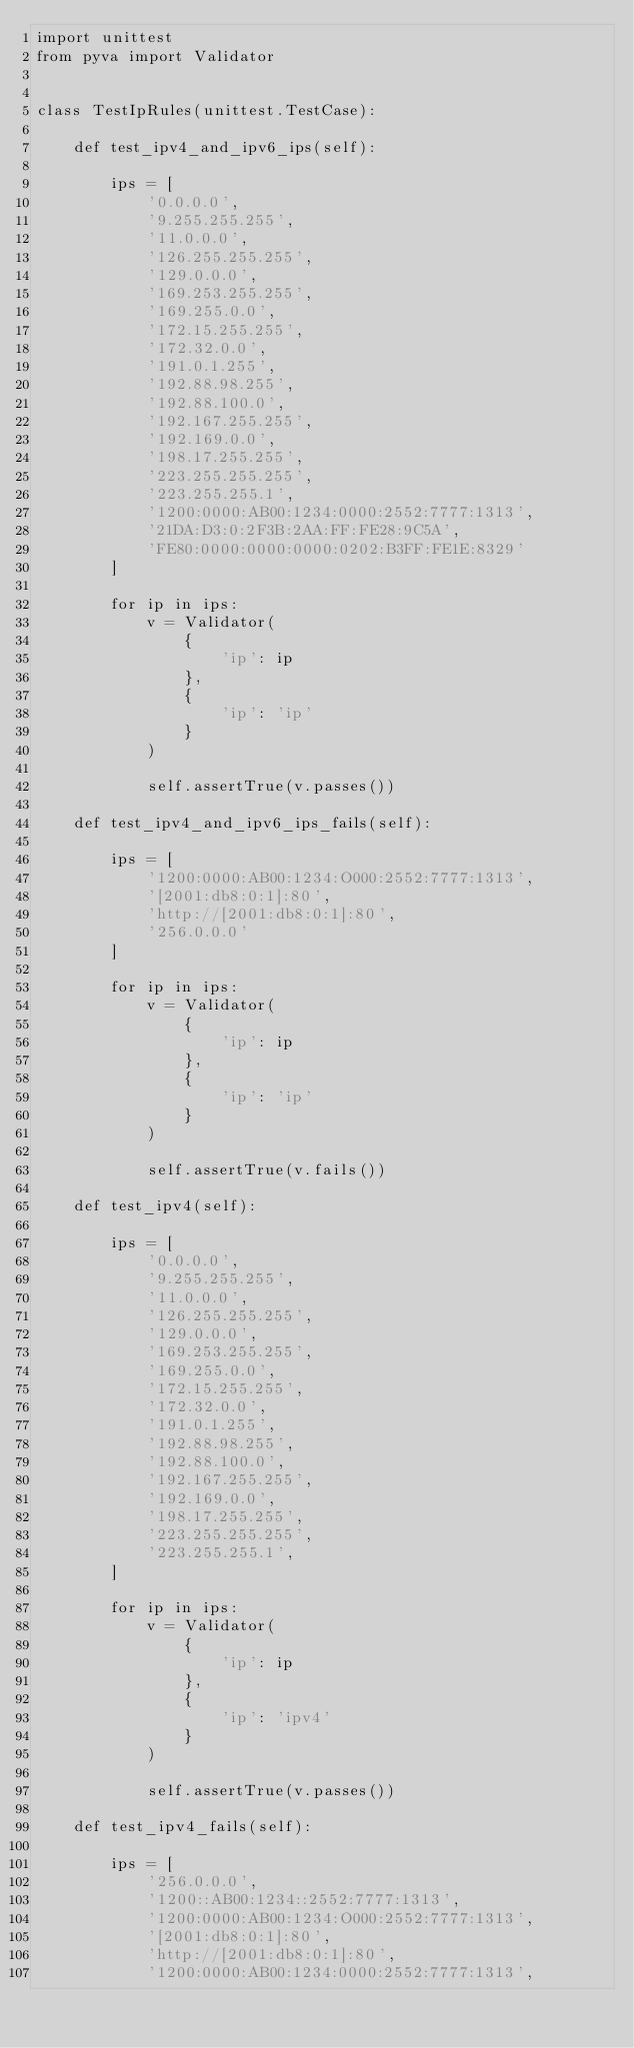Convert code to text. <code><loc_0><loc_0><loc_500><loc_500><_Python_>import unittest
from pyva import Validator


class TestIpRules(unittest.TestCase):

    def test_ipv4_and_ipv6_ips(self):

        ips = [
            '0.0.0.0',
            '9.255.255.255',
            '11.0.0.0',
            '126.255.255.255',
            '129.0.0.0',
            '169.253.255.255',
            '169.255.0.0',
            '172.15.255.255',
            '172.32.0.0',
            '191.0.1.255',
            '192.88.98.255',
            '192.88.100.0',
            '192.167.255.255',
            '192.169.0.0',
            '198.17.255.255',
            '223.255.255.255',
            '223.255.255.1',
            '1200:0000:AB00:1234:0000:2552:7777:1313',
            '21DA:D3:0:2F3B:2AA:FF:FE28:9C5A',
            'FE80:0000:0000:0000:0202:B3FF:FE1E:8329'
        ]

        for ip in ips:
            v = Validator(
                {
                    'ip': ip
                },
                {
                    'ip': 'ip'
                }
            )

            self.assertTrue(v.passes())

    def test_ipv4_and_ipv6_ips_fails(self):

        ips = [
            '1200:0000:AB00:1234:O000:2552:7777:1313',
            '[2001:db8:0:1]:80',
            'http://[2001:db8:0:1]:80',
            '256.0.0.0'
        ]

        for ip in ips:
            v = Validator(
                {
                    'ip': ip
                },
                {
                    'ip': 'ip'
                }
            )

            self.assertTrue(v.fails())

    def test_ipv4(self):

        ips = [
            '0.0.0.0',
            '9.255.255.255',
            '11.0.0.0',
            '126.255.255.255',
            '129.0.0.0',
            '169.253.255.255',
            '169.255.0.0',
            '172.15.255.255',
            '172.32.0.0',
            '191.0.1.255',
            '192.88.98.255',
            '192.88.100.0',
            '192.167.255.255',
            '192.169.0.0',
            '198.17.255.255',
            '223.255.255.255',
            '223.255.255.1',
        ]

        for ip in ips:
            v = Validator(
                {
                    'ip': ip
                },
                {
                    'ip': 'ipv4'
                }
            )

            self.assertTrue(v.passes())

    def test_ipv4_fails(self):

        ips = [
            '256.0.0.0',
            '1200::AB00:1234::2552:7777:1313',
            '1200:0000:AB00:1234:O000:2552:7777:1313',
            '[2001:db8:0:1]:80',
            'http://[2001:db8:0:1]:80',
            '1200:0000:AB00:1234:0000:2552:7777:1313',</code> 